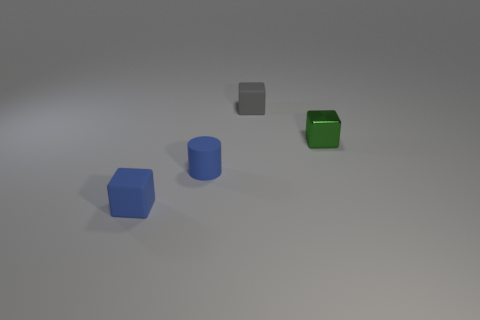Subtract all gray rubber cubes. How many cubes are left? 2 Add 1 matte cylinders. How many objects exist? 5 Subtract all blue cubes. How many cubes are left? 2 Subtract all cubes. How many objects are left? 1 Subtract 1 cubes. How many cubes are left? 2 Subtract all gray cylinders. Subtract all purple blocks. How many cylinders are left? 1 Subtract all yellow cylinders. How many cyan cubes are left? 0 Subtract all tiny gray matte cubes. Subtract all blue things. How many objects are left? 1 Add 4 small objects. How many small objects are left? 8 Add 4 blue cylinders. How many blue cylinders exist? 5 